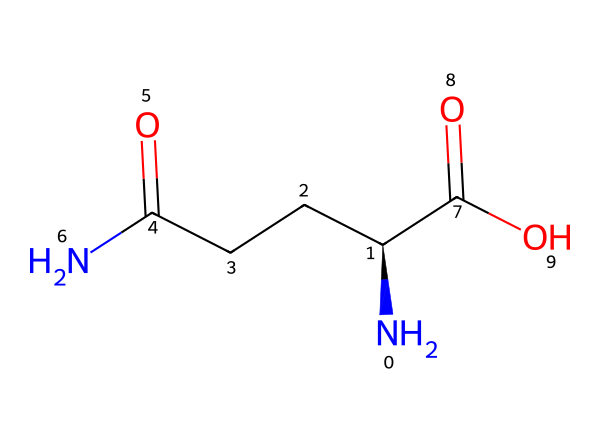What is the main functional group present in L-glutamine? The structure of L-glutamine contains the carboxylic acid group (-COOH) and an amine group (-NH2). The presence of these makes the carboxylic acid the main functional group.
Answer: carboxylic acid How many carbon atoms are present in L-glutamine? Analyzing the SMILES representation, we identify three carbon atoms in the carbon chain and one in the carboxylic acid, totaling four carbon atoms.
Answer: four What type of bonding is predominantly seen in the backbone of L-glutamine? The backbone of L-glutamine consists of single (sigma) bonds among the carbon, nitrogen, and oxygen, with the double bonds present in the carbonyl groups but predominantly single bonds overall.
Answer: single bonds Does L-glutamine display any hypervalent bonding? Hypervalent bonding involves atoms surpassing the octet rule. L-glutamine does not exhibit hypervalent bonding as all atoms abide by the octet rule.
Answer: no What is the stereochemistry configuration of the chiral center in L-glutamine? The chiral center is represented as C@@H in the SMILES notation, indicating it has an "S" configuration based on the specific arrangement of substituents around it.
Answer: S How many total nitrogen atoms are there in L-glutamine? Reviewing the SMILES, we find one amine nitrogen and one amide nitrogen, adding up to two nitrogen atoms.
Answer: two Is L-glutamine classified as a polar or nonpolar compound? The presence of the polar amine and carboxylic acid groups, along with the electronegativity differences, classify L-glutamine as a polar compound.
Answer: polar 